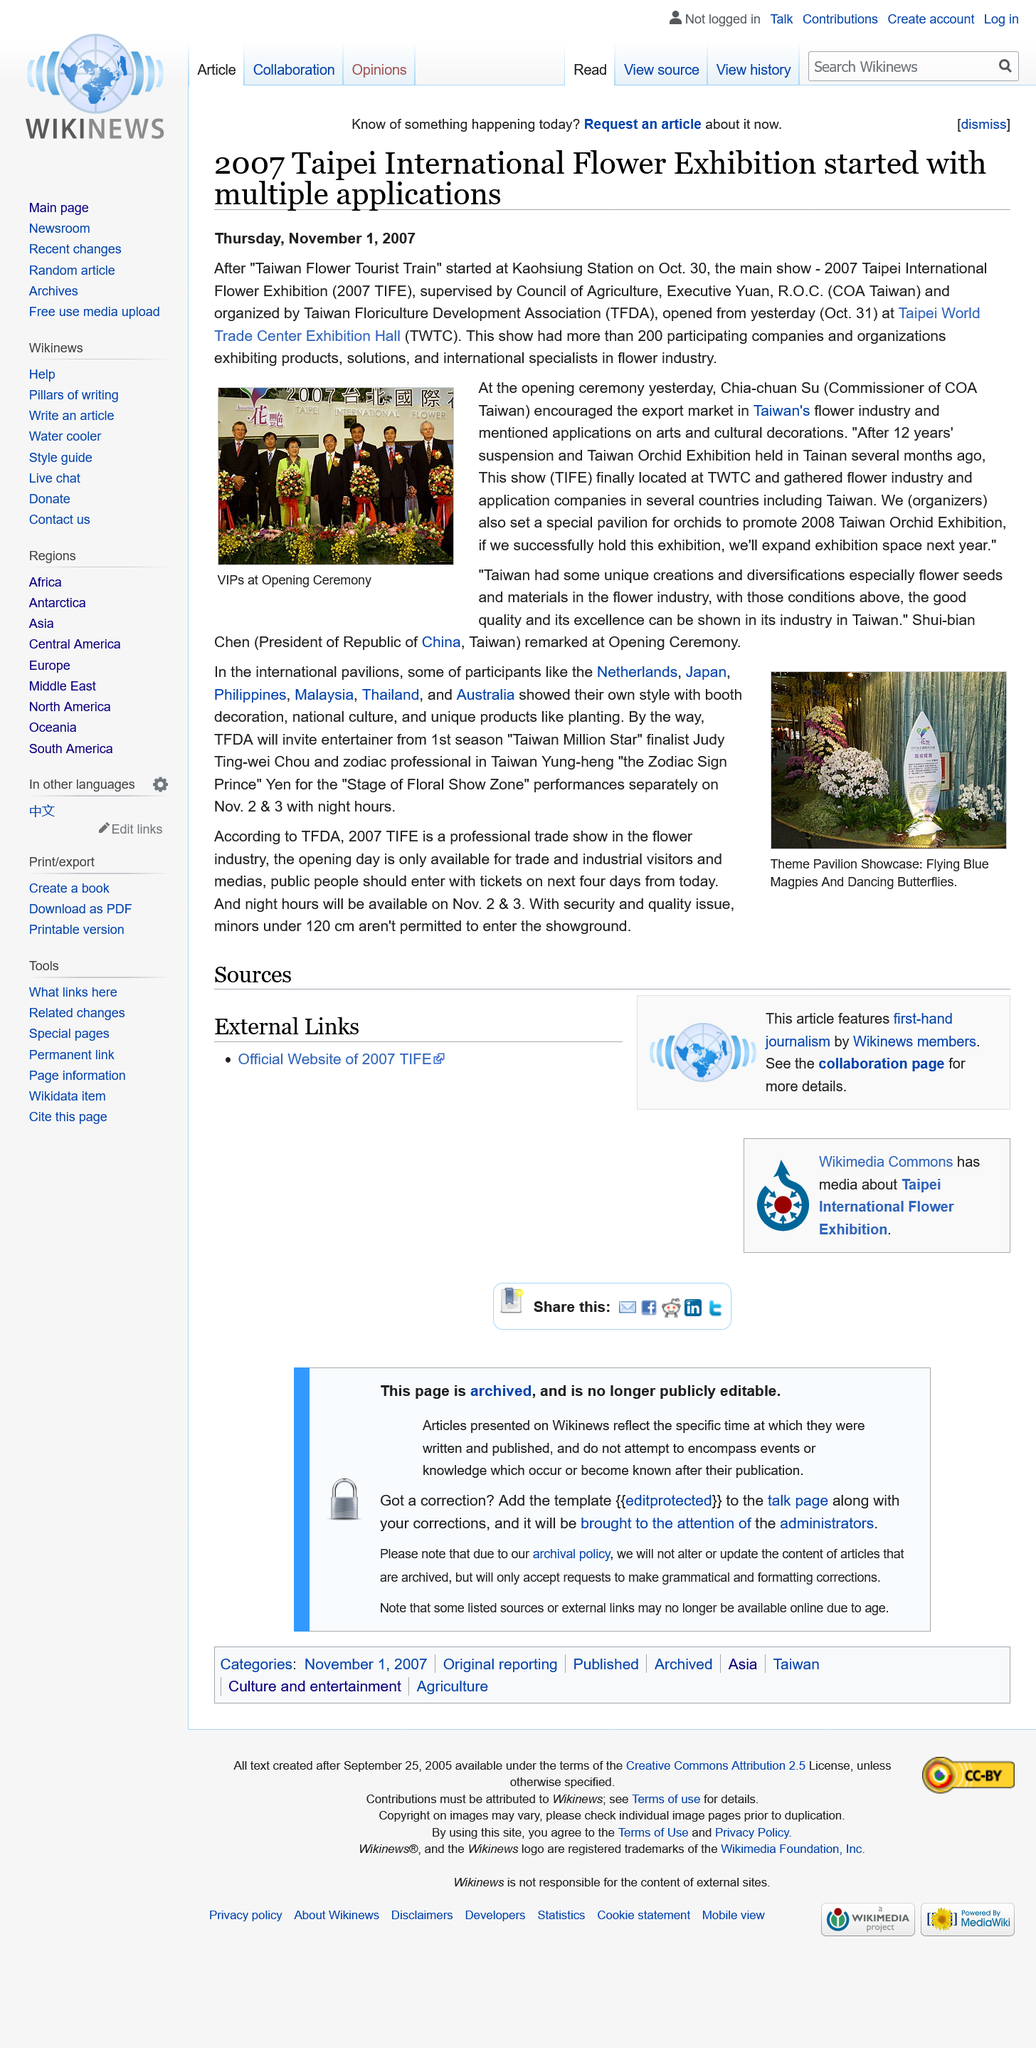Outline some significant characteristics in this image. In 2007, Chia-chuan Su was the commissioner of the Control Yuan of Taiwan. The Taipei International Flower Exhibition, also commonly referred to as the Taipei International Flower Show and abbreviated as TIFE, is a well-known event that showcases a wide variety of flowers and garden-related products and services. The 2007 Taipei International Flower Exhibition was held at the Trade Center Exhibition Hall in Taiwan. 